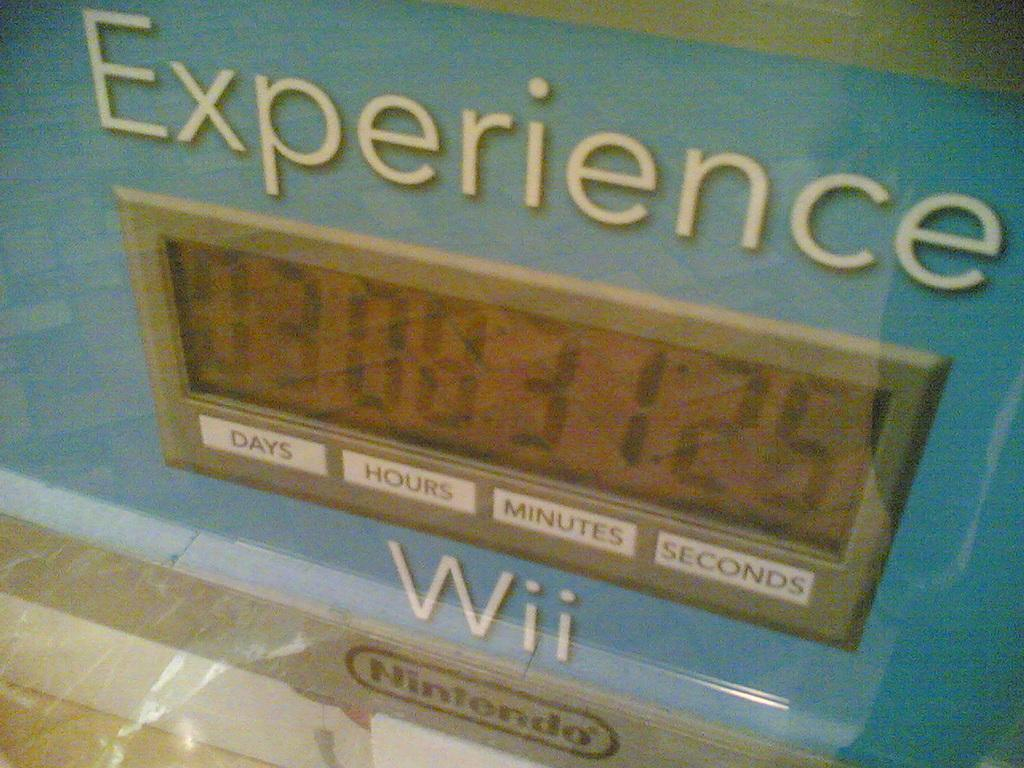<image>
Relay a brief, clear account of the picture shown. wooden board for measuring time for Nintendo Wii system 